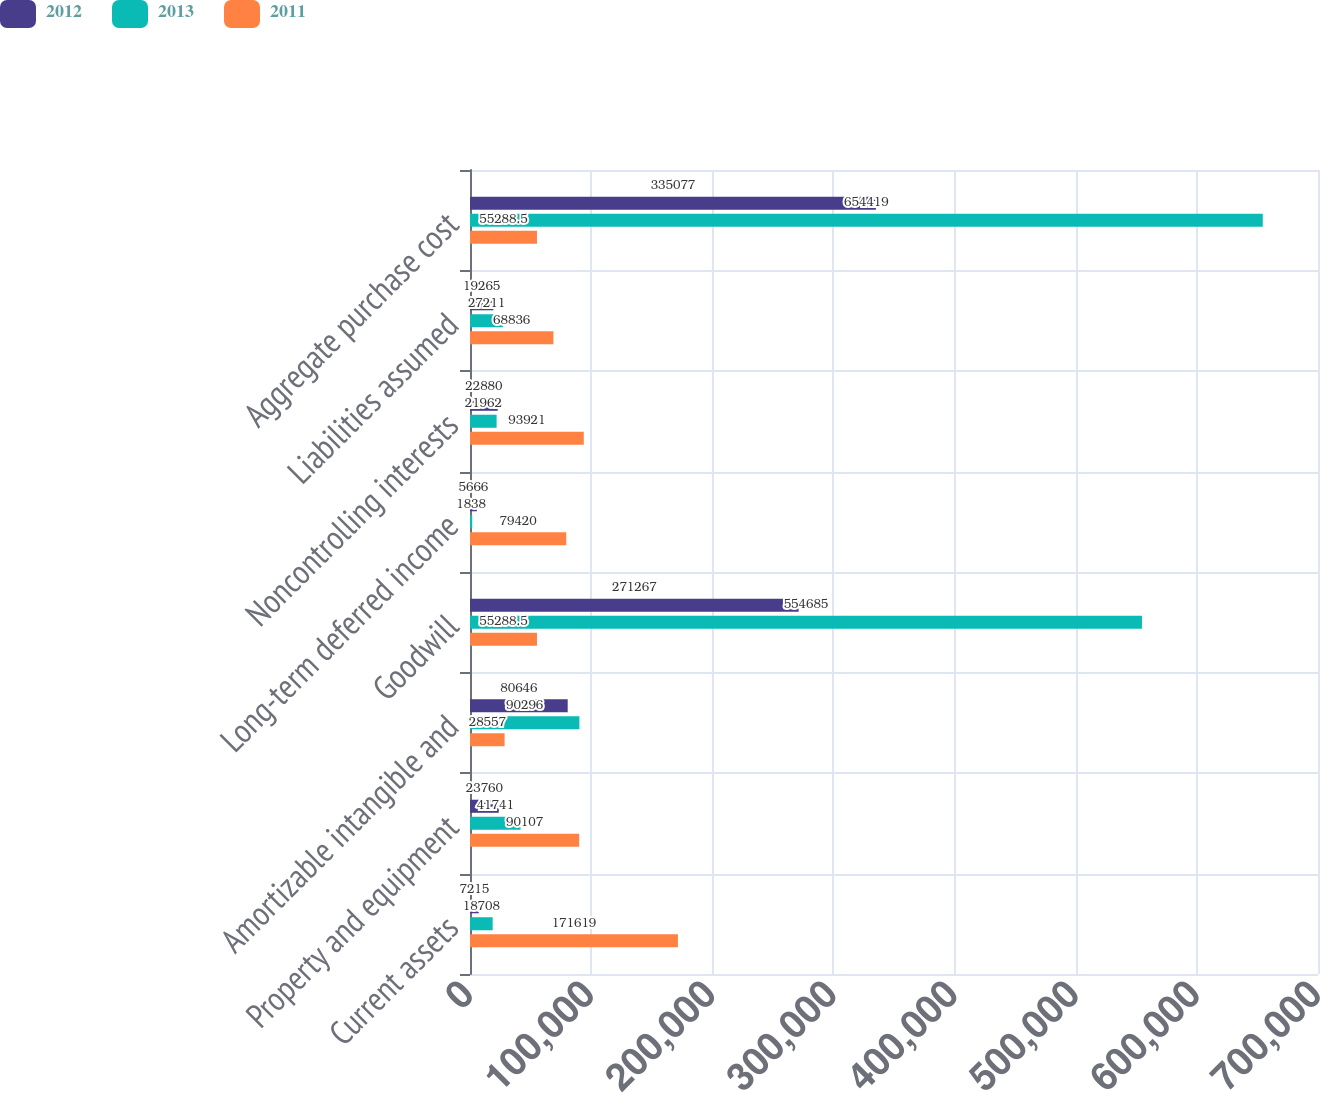Convert chart. <chart><loc_0><loc_0><loc_500><loc_500><stacked_bar_chart><ecel><fcel>Current assets<fcel>Property and equipment<fcel>Amortizable intangible and<fcel>Goodwill<fcel>Long-term deferred income<fcel>Noncontrolling interests<fcel>Liabilities assumed<fcel>Aggregate purchase cost<nl><fcel>2012<fcel>7215<fcel>23760<fcel>80646<fcel>271267<fcel>5666<fcel>22880<fcel>19265<fcel>335077<nl><fcel>2013<fcel>18708<fcel>41741<fcel>90296<fcel>554685<fcel>1838<fcel>21962<fcel>27211<fcel>654419<nl><fcel>2011<fcel>171619<fcel>90107<fcel>28557<fcel>55288.5<fcel>79420<fcel>93921<fcel>68836<fcel>55288.5<nl></chart> 